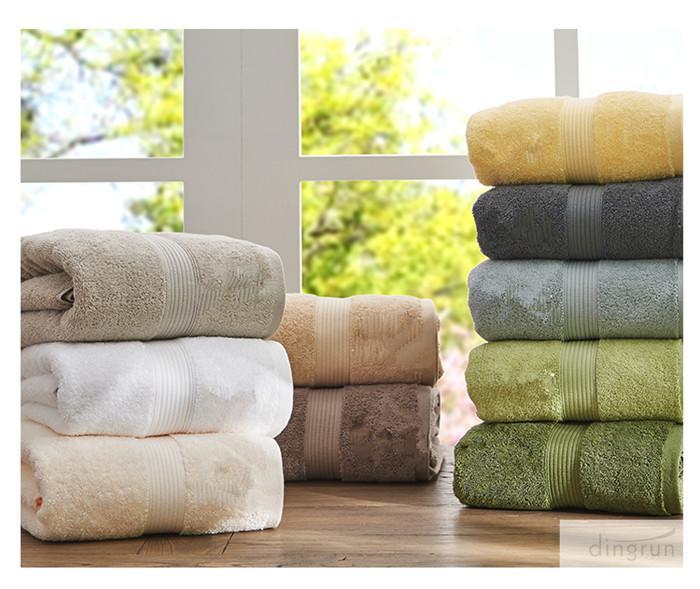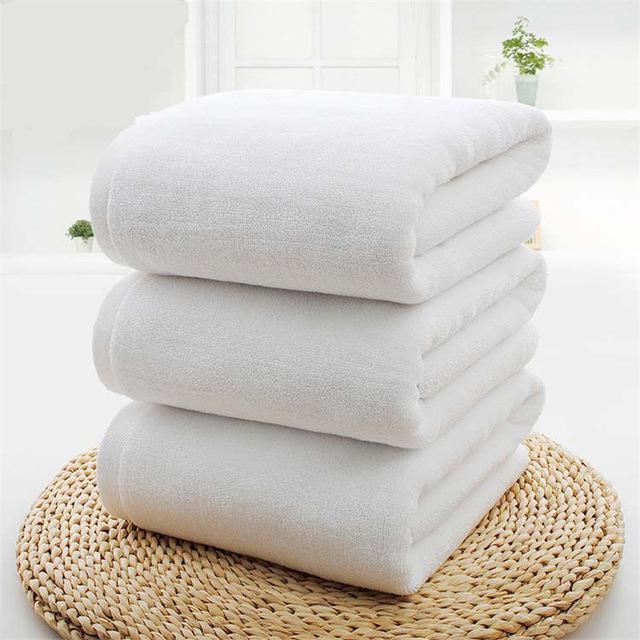The first image is the image on the left, the second image is the image on the right. For the images displayed, is the sentence "Both images contain a stack of three white towels with embroidery on the bottom." factually correct? Answer yes or no. No. The first image is the image on the left, the second image is the image on the right. Given the left and right images, does the statement "All the towels are monogrammed." hold true? Answer yes or no. No. 